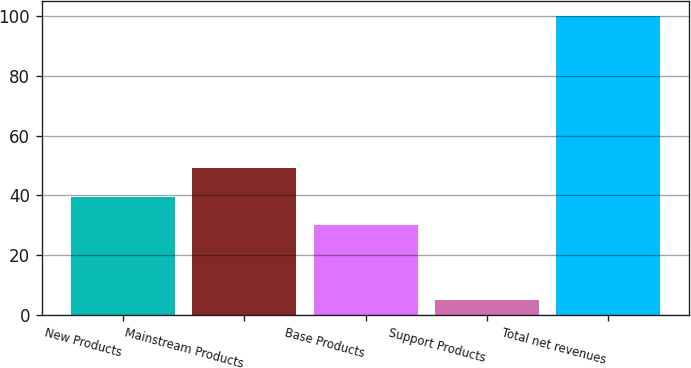Convert chart. <chart><loc_0><loc_0><loc_500><loc_500><bar_chart><fcel>New Products<fcel>Mainstream Products<fcel>Base Products<fcel>Support Products<fcel>Total net revenues<nl><fcel>39.5<fcel>49<fcel>30<fcel>5<fcel>100<nl></chart> 